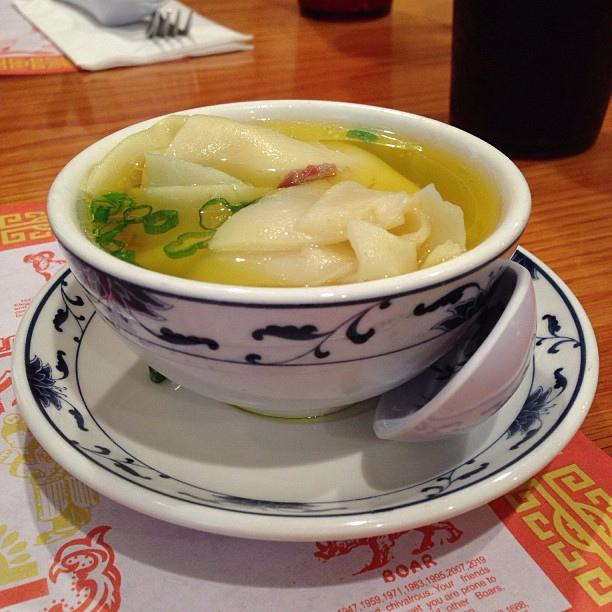What is traditionally eaten as an accompaniment to this dish?

Choices:
A) bread
B) fruit
C) eggs
D) cake bread 